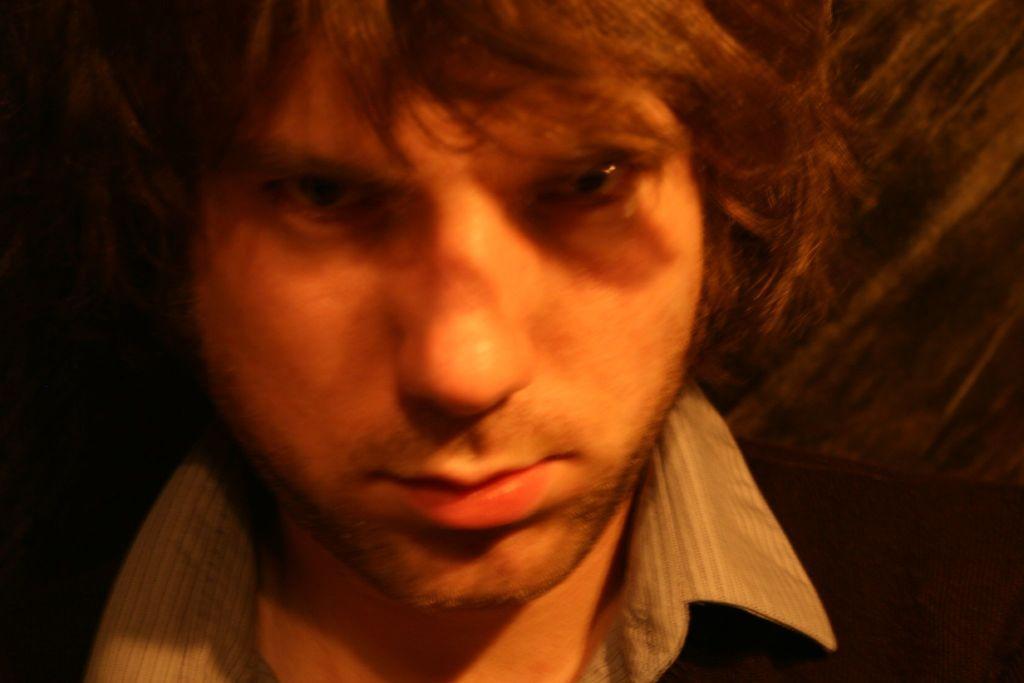Please provide a concise description of this image. This image consists of a person. He is the man. Only the face is visible. He has eyes, nose, mouth, hair. 